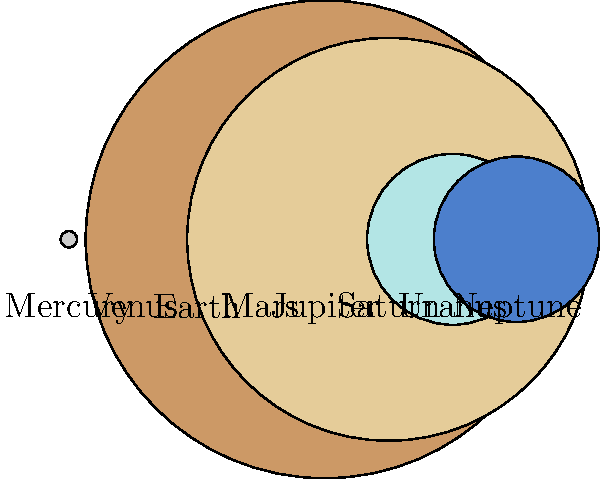In this nostalgic journey through our solar system, reminiscent of Baccara's cosmic melodies, which planet is represented by the second largest circle? Let's approach this step-by-step, just like we used to analyze Baccara's lyrics:

1. First, we need to identify all the planets represented in the image. From left to right, we have Mercury, Venus, Earth, Mars, Jupiter, Saturn, Uranus, and Neptune.

2. Now, we need to compare the sizes of the circles representing each planet:
   - Jupiter is clearly the largest circle
   - Saturn is the second largest
   - Uranus and Neptune are similar in size, but smaller than Saturn
   - Earth and Venus are much smaller, but similar to each other
   - Mars and Mercury are the smallest

3. The question asks for the second largest circle, which corresponds to the second largest planet representation.

4. By visual inspection, we can clearly see that Saturn is represented by the second largest circle.

5. This aligns with our knowledge of the solar system: Jupiter is the largest planet, followed by Saturn.

Just as Baccara's "Yes Sir, I Can Boogie" was their second-biggest hit after "Sorry, I'm a Lady," Saturn is the second-largest planet after Jupiter in our solar system.
Answer: Saturn 